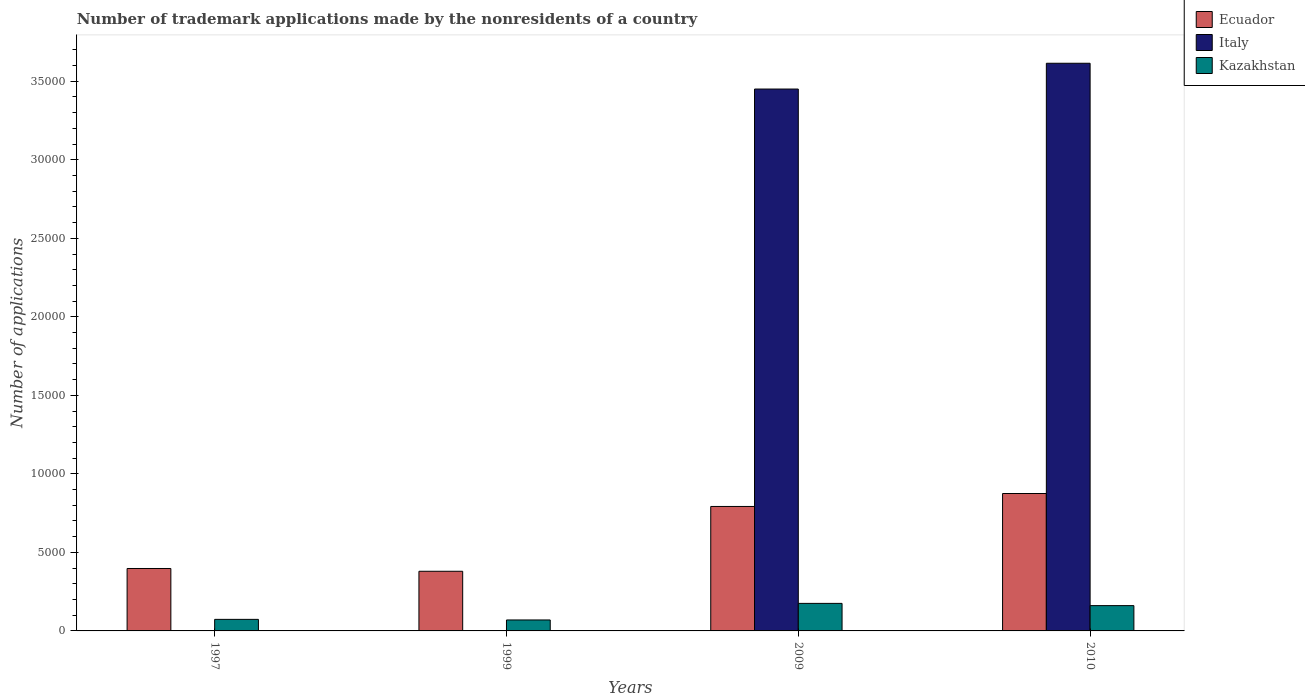Are the number of bars per tick equal to the number of legend labels?
Keep it short and to the point. Yes. Are the number of bars on each tick of the X-axis equal?
Make the answer very short. Yes. How many bars are there on the 3rd tick from the left?
Offer a very short reply. 3. What is the label of the 3rd group of bars from the left?
Your answer should be compact. 2009. What is the number of trademark applications made by the nonresidents in Ecuador in 1997?
Your response must be concise. 3975. Across all years, what is the maximum number of trademark applications made by the nonresidents in Kazakhstan?
Give a very brief answer. 1754. Across all years, what is the minimum number of trademark applications made by the nonresidents in Ecuador?
Give a very brief answer. 3798. What is the total number of trademark applications made by the nonresidents in Ecuador in the graph?
Provide a succinct answer. 2.44e+04. What is the difference between the number of trademark applications made by the nonresidents in Ecuador in 2009 and that in 2010?
Offer a terse response. -825. What is the difference between the number of trademark applications made by the nonresidents in Kazakhstan in 2009 and the number of trademark applications made by the nonresidents in Ecuador in 1999?
Keep it short and to the point. -2044. What is the average number of trademark applications made by the nonresidents in Ecuador per year?
Your answer should be compact. 6112. In the year 1997, what is the difference between the number of trademark applications made by the nonresidents in Ecuador and number of trademark applications made by the nonresidents in Kazakhstan?
Make the answer very short. 3239. In how many years, is the number of trademark applications made by the nonresidents in Italy greater than 17000?
Make the answer very short. 2. What is the ratio of the number of trademark applications made by the nonresidents in Italy in 1999 to that in 2010?
Make the answer very short. 2.7664047803474603e-5. Is the number of trademark applications made by the nonresidents in Ecuador in 1997 less than that in 2009?
Keep it short and to the point. Yes. Is the difference between the number of trademark applications made by the nonresidents in Ecuador in 1999 and 2009 greater than the difference between the number of trademark applications made by the nonresidents in Kazakhstan in 1999 and 2009?
Your answer should be compact. No. What is the difference between the highest and the second highest number of trademark applications made by the nonresidents in Kazakhstan?
Ensure brevity in your answer.  143. What is the difference between the highest and the lowest number of trademark applications made by the nonresidents in Italy?
Keep it short and to the point. 3.61e+04. What does the 3rd bar from the left in 1997 represents?
Give a very brief answer. Kazakhstan. What does the 3rd bar from the right in 2009 represents?
Offer a very short reply. Ecuador. Is it the case that in every year, the sum of the number of trademark applications made by the nonresidents in Kazakhstan and number of trademark applications made by the nonresidents in Italy is greater than the number of trademark applications made by the nonresidents in Ecuador?
Provide a succinct answer. No. How many bars are there?
Make the answer very short. 12. What is the difference between two consecutive major ticks on the Y-axis?
Your answer should be compact. 5000. Are the values on the major ticks of Y-axis written in scientific E-notation?
Your answer should be very brief. No. Does the graph contain any zero values?
Ensure brevity in your answer.  No. Where does the legend appear in the graph?
Make the answer very short. Top right. How are the legend labels stacked?
Your response must be concise. Vertical. What is the title of the graph?
Ensure brevity in your answer.  Number of trademark applications made by the nonresidents of a country. Does "Liechtenstein" appear as one of the legend labels in the graph?
Keep it short and to the point. No. What is the label or title of the X-axis?
Offer a very short reply. Years. What is the label or title of the Y-axis?
Your response must be concise. Number of applications. What is the Number of applications in Ecuador in 1997?
Provide a short and direct response. 3975. What is the Number of applications in Italy in 1997?
Provide a short and direct response. 1. What is the Number of applications of Kazakhstan in 1997?
Give a very brief answer. 736. What is the Number of applications of Ecuador in 1999?
Keep it short and to the point. 3798. What is the Number of applications of Kazakhstan in 1999?
Your response must be concise. 698. What is the Number of applications of Ecuador in 2009?
Your answer should be compact. 7925. What is the Number of applications in Italy in 2009?
Your response must be concise. 3.45e+04. What is the Number of applications in Kazakhstan in 2009?
Provide a short and direct response. 1754. What is the Number of applications in Ecuador in 2010?
Keep it short and to the point. 8750. What is the Number of applications of Italy in 2010?
Your response must be concise. 3.61e+04. What is the Number of applications in Kazakhstan in 2010?
Give a very brief answer. 1611. Across all years, what is the maximum Number of applications in Ecuador?
Your answer should be very brief. 8750. Across all years, what is the maximum Number of applications in Italy?
Your response must be concise. 3.61e+04. Across all years, what is the maximum Number of applications in Kazakhstan?
Offer a very short reply. 1754. Across all years, what is the minimum Number of applications of Ecuador?
Give a very brief answer. 3798. Across all years, what is the minimum Number of applications in Kazakhstan?
Make the answer very short. 698. What is the total Number of applications in Ecuador in the graph?
Give a very brief answer. 2.44e+04. What is the total Number of applications of Italy in the graph?
Provide a short and direct response. 7.07e+04. What is the total Number of applications in Kazakhstan in the graph?
Ensure brevity in your answer.  4799. What is the difference between the Number of applications of Ecuador in 1997 and that in 1999?
Offer a very short reply. 177. What is the difference between the Number of applications of Italy in 1997 and that in 1999?
Provide a short and direct response. 0. What is the difference between the Number of applications of Kazakhstan in 1997 and that in 1999?
Provide a short and direct response. 38. What is the difference between the Number of applications of Ecuador in 1997 and that in 2009?
Make the answer very short. -3950. What is the difference between the Number of applications of Italy in 1997 and that in 2009?
Your response must be concise. -3.45e+04. What is the difference between the Number of applications of Kazakhstan in 1997 and that in 2009?
Give a very brief answer. -1018. What is the difference between the Number of applications of Ecuador in 1997 and that in 2010?
Your response must be concise. -4775. What is the difference between the Number of applications of Italy in 1997 and that in 2010?
Ensure brevity in your answer.  -3.61e+04. What is the difference between the Number of applications in Kazakhstan in 1997 and that in 2010?
Provide a short and direct response. -875. What is the difference between the Number of applications of Ecuador in 1999 and that in 2009?
Make the answer very short. -4127. What is the difference between the Number of applications in Italy in 1999 and that in 2009?
Keep it short and to the point. -3.45e+04. What is the difference between the Number of applications of Kazakhstan in 1999 and that in 2009?
Make the answer very short. -1056. What is the difference between the Number of applications in Ecuador in 1999 and that in 2010?
Offer a very short reply. -4952. What is the difference between the Number of applications in Italy in 1999 and that in 2010?
Keep it short and to the point. -3.61e+04. What is the difference between the Number of applications of Kazakhstan in 1999 and that in 2010?
Your response must be concise. -913. What is the difference between the Number of applications of Ecuador in 2009 and that in 2010?
Make the answer very short. -825. What is the difference between the Number of applications in Italy in 2009 and that in 2010?
Offer a very short reply. -1642. What is the difference between the Number of applications in Kazakhstan in 2009 and that in 2010?
Your response must be concise. 143. What is the difference between the Number of applications of Ecuador in 1997 and the Number of applications of Italy in 1999?
Give a very brief answer. 3974. What is the difference between the Number of applications of Ecuador in 1997 and the Number of applications of Kazakhstan in 1999?
Give a very brief answer. 3277. What is the difference between the Number of applications of Italy in 1997 and the Number of applications of Kazakhstan in 1999?
Ensure brevity in your answer.  -697. What is the difference between the Number of applications in Ecuador in 1997 and the Number of applications in Italy in 2009?
Your response must be concise. -3.05e+04. What is the difference between the Number of applications of Ecuador in 1997 and the Number of applications of Kazakhstan in 2009?
Keep it short and to the point. 2221. What is the difference between the Number of applications in Italy in 1997 and the Number of applications in Kazakhstan in 2009?
Ensure brevity in your answer.  -1753. What is the difference between the Number of applications of Ecuador in 1997 and the Number of applications of Italy in 2010?
Offer a terse response. -3.22e+04. What is the difference between the Number of applications in Ecuador in 1997 and the Number of applications in Kazakhstan in 2010?
Give a very brief answer. 2364. What is the difference between the Number of applications in Italy in 1997 and the Number of applications in Kazakhstan in 2010?
Make the answer very short. -1610. What is the difference between the Number of applications in Ecuador in 1999 and the Number of applications in Italy in 2009?
Give a very brief answer. -3.07e+04. What is the difference between the Number of applications in Ecuador in 1999 and the Number of applications in Kazakhstan in 2009?
Offer a terse response. 2044. What is the difference between the Number of applications of Italy in 1999 and the Number of applications of Kazakhstan in 2009?
Make the answer very short. -1753. What is the difference between the Number of applications in Ecuador in 1999 and the Number of applications in Italy in 2010?
Offer a terse response. -3.24e+04. What is the difference between the Number of applications of Ecuador in 1999 and the Number of applications of Kazakhstan in 2010?
Provide a short and direct response. 2187. What is the difference between the Number of applications of Italy in 1999 and the Number of applications of Kazakhstan in 2010?
Make the answer very short. -1610. What is the difference between the Number of applications in Ecuador in 2009 and the Number of applications in Italy in 2010?
Your answer should be very brief. -2.82e+04. What is the difference between the Number of applications of Ecuador in 2009 and the Number of applications of Kazakhstan in 2010?
Keep it short and to the point. 6314. What is the difference between the Number of applications in Italy in 2009 and the Number of applications in Kazakhstan in 2010?
Make the answer very short. 3.29e+04. What is the average Number of applications in Ecuador per year?
Give a very brief answer. 6112. What is the average Number of applications of Italy per year?
Provide a short and direct response. 1.77e+04. What is the average Number of applications in Kazakhstan per year?
Your answer should be very brief. 1199.75. In the year 1997, what is the difference between the Number of applications in Ecuador and Number of applications in Italy?
Make the answer very short. 3974. In the year 1997, what is the difference between the Number of applications in Ecuador and Number of applications in Kazakhstan?
Your answer should be very brief. 3239. In the year 1997, what is the difference between the Number of applications of Italy and Number of applications of Kazakhstan?
Offer a terse response. -735. In the year 1999, what is the difference between the Number of applications in Ecuador and Number of applications in Italy?
Make the answer very short. 3797. In the year 1999, what is the difference between the Number of applications in Ecuador and Number of applications in Kazakhstan?
Ensure brevity in your answer.  3100. In the year 1999, what is the difference between the Number of applications of Italy and Number of applications of Kazakhstan?
Make the answer very short. -697. In the year 2009, what is the difference between the Number of applications of Ecuador and Number of applications of Italy?
Make the answer very short. -2.66e+04. In the year 2009, what is the difference between the Number of applications in Ecuador and Number of applications in Kazakhstan?
Ensure brevity in your answer.  6171. In the year 2009, what is the difference between the Number of applications of Italy and Number of applications of Kazakhstan?
Your answer should be compact. 3.28e+04. In the year 2010, what is the difference between the Number of applications in Ecuador and Number of applications in Italy?
Your answer should be compact. -2.74e+04. In the year 2010, what is the difference between the Number of applications of Ecuador and Number of applications of Kazakhstan?
Provide a succinct answer. 7139. In the year 2010, what is the difference between the Number of applications in Italy and Number of applications in Kazakhstan?
Offer a very short reply. 3.45e+04. What is the ratio of the Number of applications of Ecuador in 1997 to that in 1999?
Your answer should be very brief. 1.05. What is the ratio of the Number of applications in Italy in 1997 to that in 1999?
Offer a very short reply. 1. What is the ratio of the Number of applications in Kazakhstan in 1997 to that in 1999?
Give a very brief answer. 1.05. What is the ratio of the Number of applications of Ecuador in 1997 to that in 2009?
Your response must be concise. 0.5. What is the ratio of the Number of applications of Kazakhstan in 1997 to that in 2009?
Offer a very short reply. 0.42. What is the ratio of the Number of applications of Ecuador in 1997 to that in 2010?
Your answer should be very brief. 0.45. What is the ratio of the Number of applications of Kazakhstan in 1997 to that in 2010?
Ensure brevity in your answer.  0.46. What is the ratio of the Number of applications of Ecuador in 1999 to that in 2009?
Give a very brief answer. 0.48. What is the ratio of the Number of applications in Kazakhstan in 1999 to that in 2009?
Give a very brief answer. 0.4. What is the ratio of the Number of applications in Ecuador in 1999 to that in 2010?
Offer a very short reply. 0.43. What is the ratio of the Number of applications in Italy in 1999 to that in 2010?
Your answer should be very brief. 0. What is the ratio of the Number of applications in Kazakhstan in 1999 to that in 2010?
Your answer should be compact. 0.43. What is the ratio of the Number of applications of Ecuador in 2009 to that in 2010?
Your answer should be compact. 0.91. What is the ratio of the Number of applications of Italy in 2009 to that in 2010?
Give a very brief answer. 0.95. What is the ratio of the Number of applications in Kazakhstan in 2009 to that in 2010?
Your answer should be compact. 1.09. What is the difference between the highest and the second highest Number of applications of Ecuador?
Your answer should be compact. 825. What is the difference between the highest and the second highest Number of applications in Italy?
Make the answer very short. 1642. What is the difference between the highest and the second highest Number of applications in Kazakhstan?
Ensure brevity in your answer.  143. What is the difference between the highest and the lowest Number of applications in Ecuador?
Give a very brief answer. 4952. What is the difference between the highest and the lowest Number of applications in Italy?
Provide a succinct answer. 3.61e+04. What is the difference between the highest and the lowest Number of applications of Kazakhstan?
Give a very brief answer. 1056. 